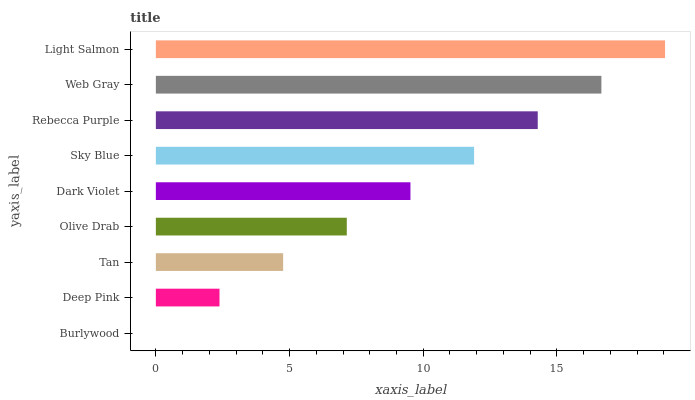Is Burlywood the minimum?
Answer yes or no. Yes. Is Light Salmon the maximum?
Answer yes or no. Yes. Is Deep Pink the minimum?
Answer yes or no. No. Is Deep Pink the maximum?
Answer yes or no. No. Is Deep Pink greater than Burlywood?
Answer yes or no. Yes. Is Burlywood less than Deep Pink?
Answer yes or no. Yes. Is Burlywood greater than Deep Pink?
Answer yes or no. No. Is Deep Pink less than Burlywood?
Answer yes or no. No. Is Dark Violet the high median?
Answer yes or no. Yes. Is Dark Violet the low median?
Answer yes or no. Yes. Is Burlywood the high median?
Answer yes or no. No. Is Sky Blue the low median?
Answer yes or no. No. 